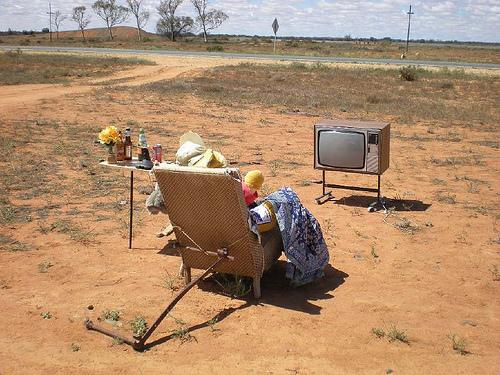Why can't they watch the television? Please explain your reasoning. no electricity. There are no outlets outside. 